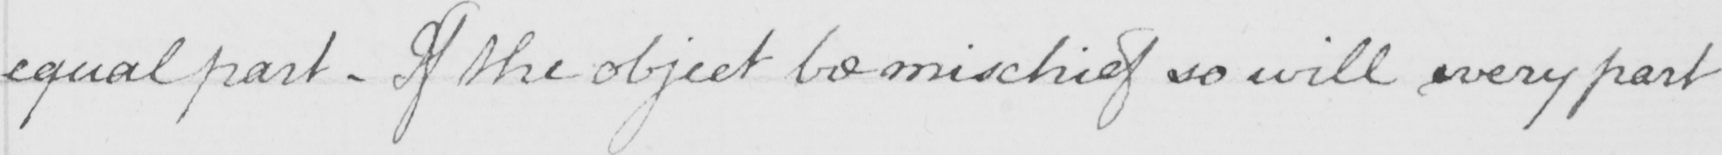Transcribe the text shown in this historical manuscript line. equal part . If the object be mischief so will every part 